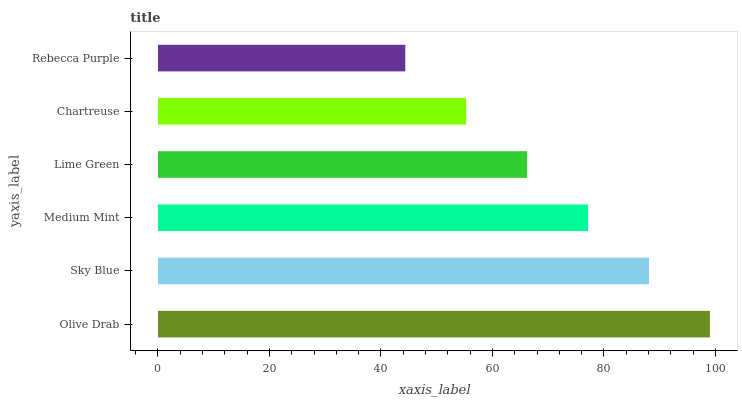Is Rebecca Purple the minimum?
Answer yes or no. Yes. Is Olive Drab the maximum?
Answer yes or no. Yes. Is Sky Blue the minimum?
Answer yes or no. No. Is Sky Blue the maximum?
Answer yes or no. No. Is Olive Drab greater than Sky Blue?
Answer yes or no. Yes. Is Sky Blue less than Olive Drab?
Answer yes or no. Yes. Is Sky Blue greater than Olive Drab?
Answer yes or no. No. Is Olive Drab less than Sky Blue?
Answer yes or no. No. Is Medium Mint the high median?
Answer yes or no. Yes. Is Lime Green the low median?
Answer yes or no. Yes. Is Rebecca Purple the high median?
Answer yes or no. No. Is Medium Mint the low median?
Answer yes or no. No. 